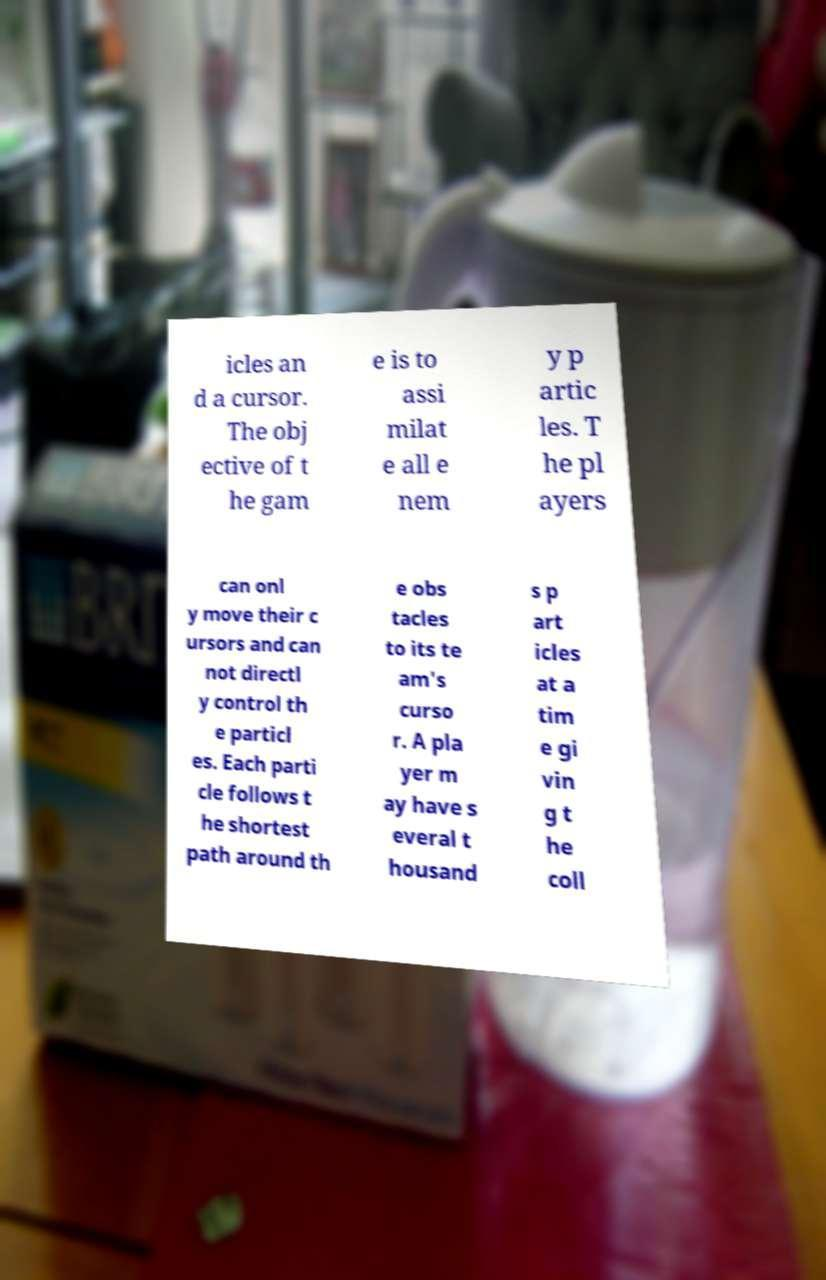For documentation purposes, I need the text within this image transcribed. Could you provide that? icles an d a cursor. The obj ective of t he gam e is to assi milat e all e nem y p artic les. T he pl ayers can onl y move their c ursors and can not directl y control th e particl es. Each parti cle follows t he shortest path around th e obs tacles to its te am's curso r. A pla yer m ay have s everal t housand s p art icles at a tim e gi vin g t he coll 